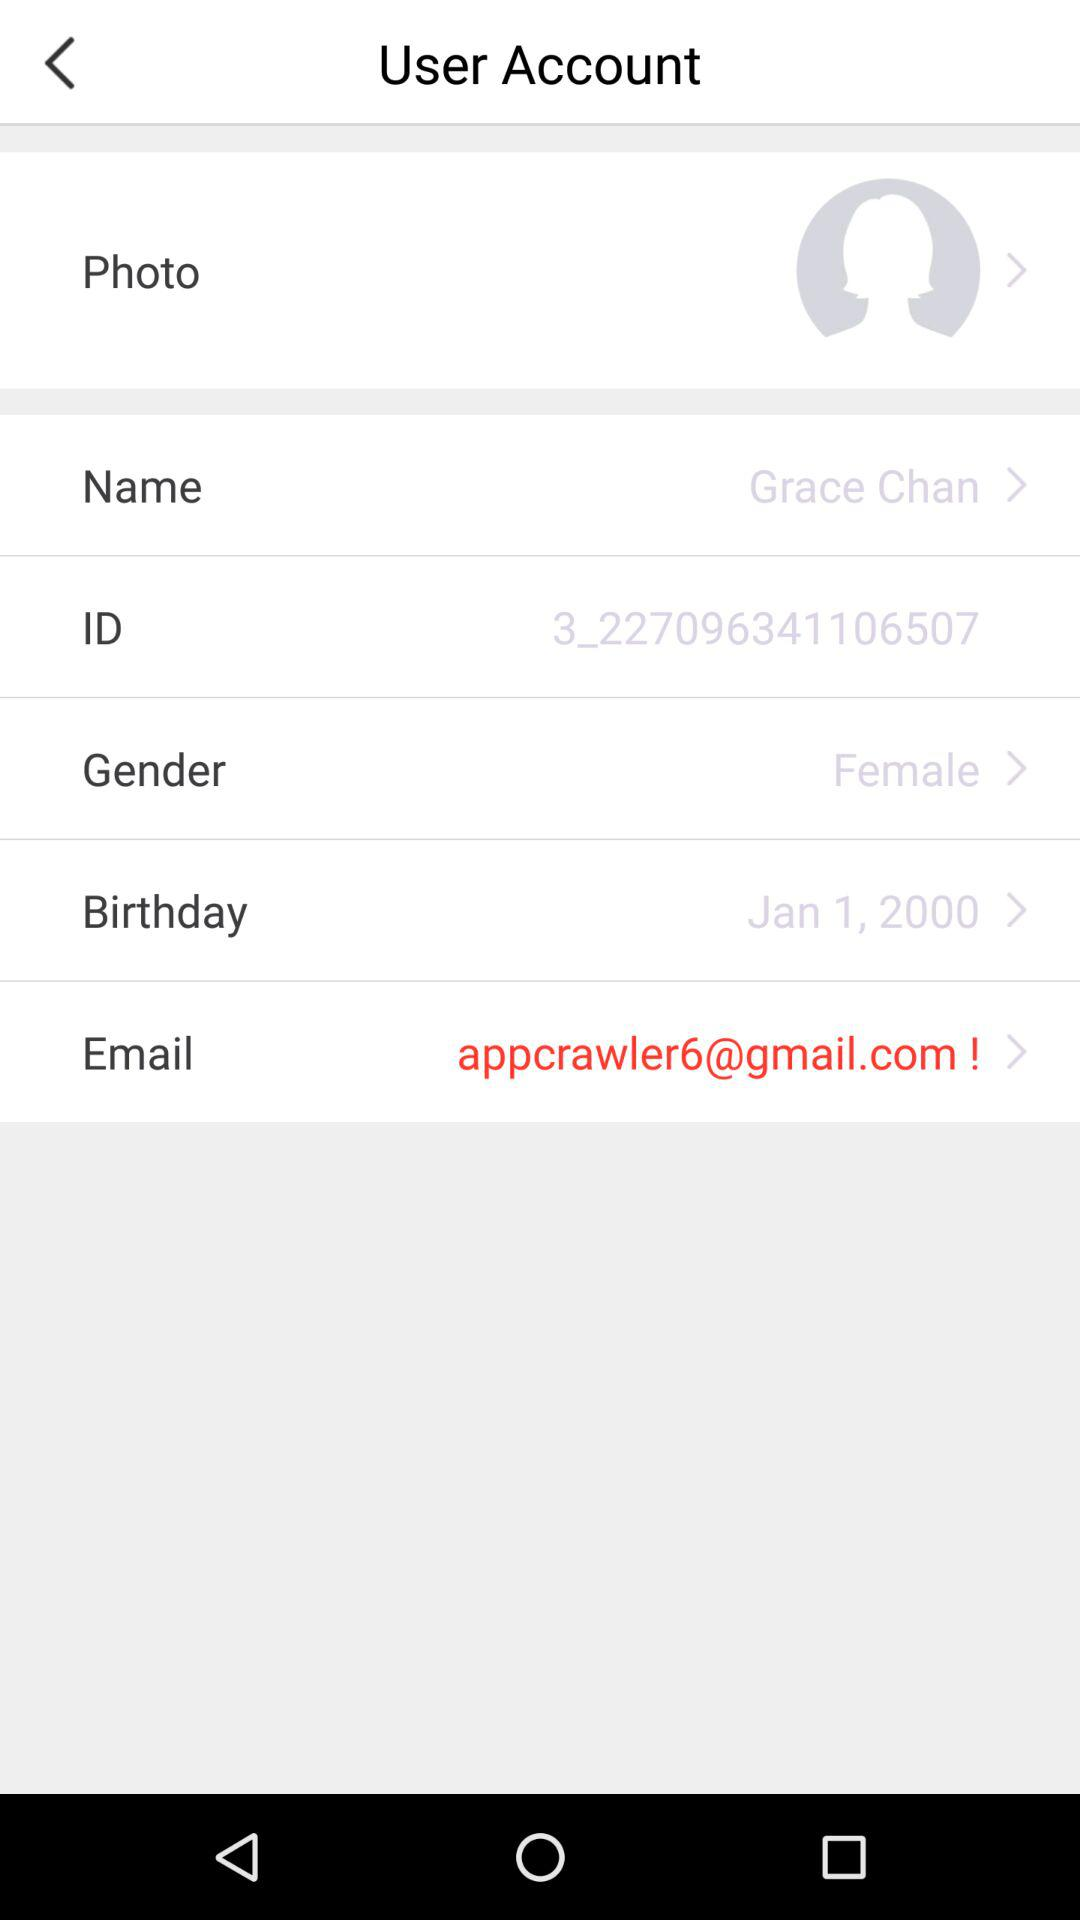What's the birth date? The birth date is January 1, 2000. 